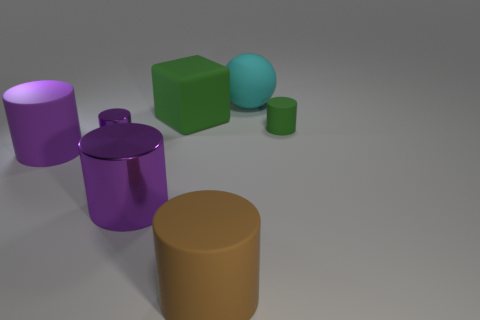What is the shape of the big green matte object? cube 